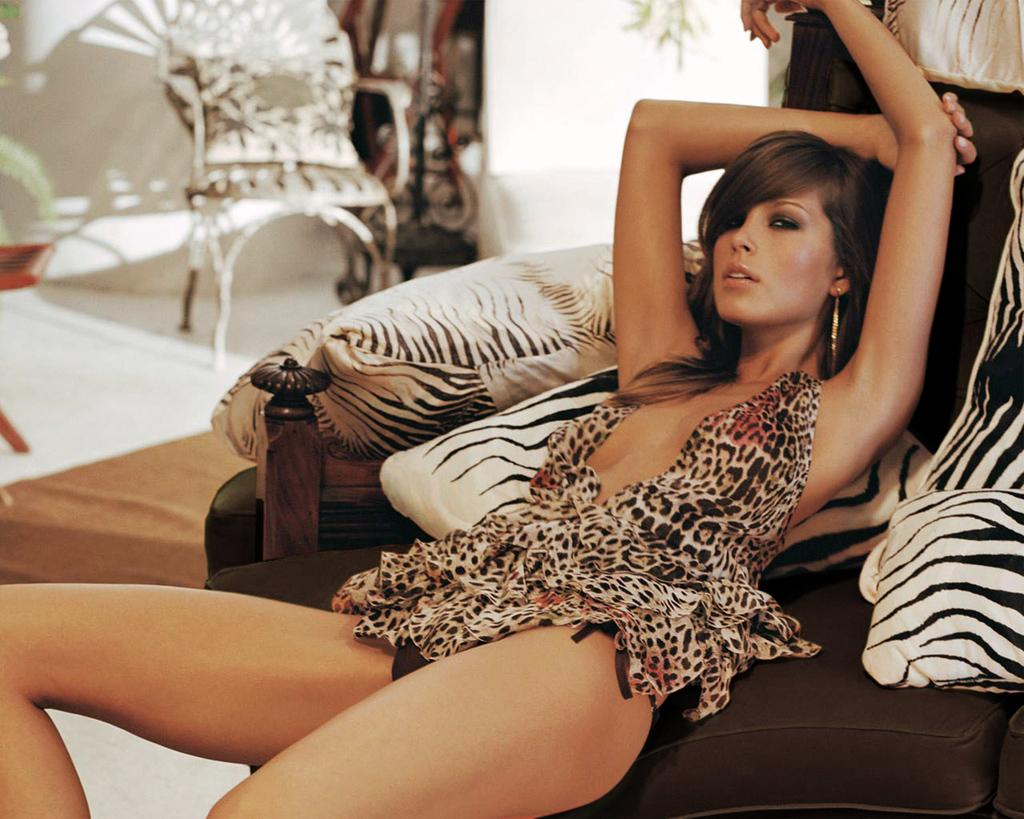Who is present in the image? There is a person in the image. What is the person doing in the image? The person is posing for a picture. What type of furniture can be seen in the image? There are chairs in the image. What type of soft furnishings are present in the image? There are pillows in the image. What type of structure is visible in the image? There is a wall in the image. What other objects can be seen in the image? There are some objects in the image. How many snails are crawling on the person's shoulder in the image? There are no snails present in the image; the person is posing for a picture without any snails on their shoulder. 